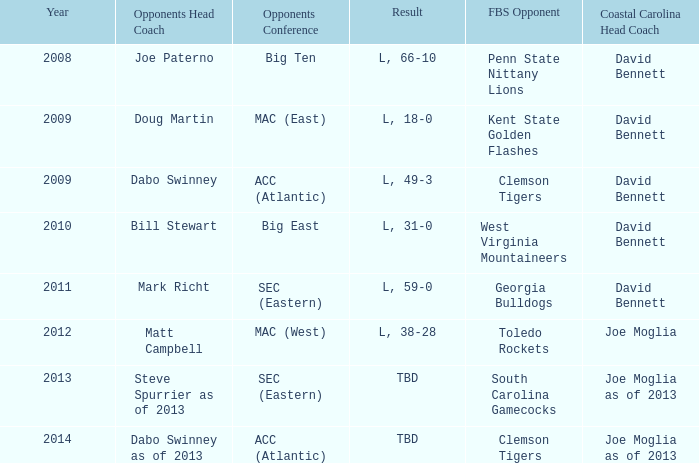How many head coaches did Kent state golden flashes have? 1.0. 